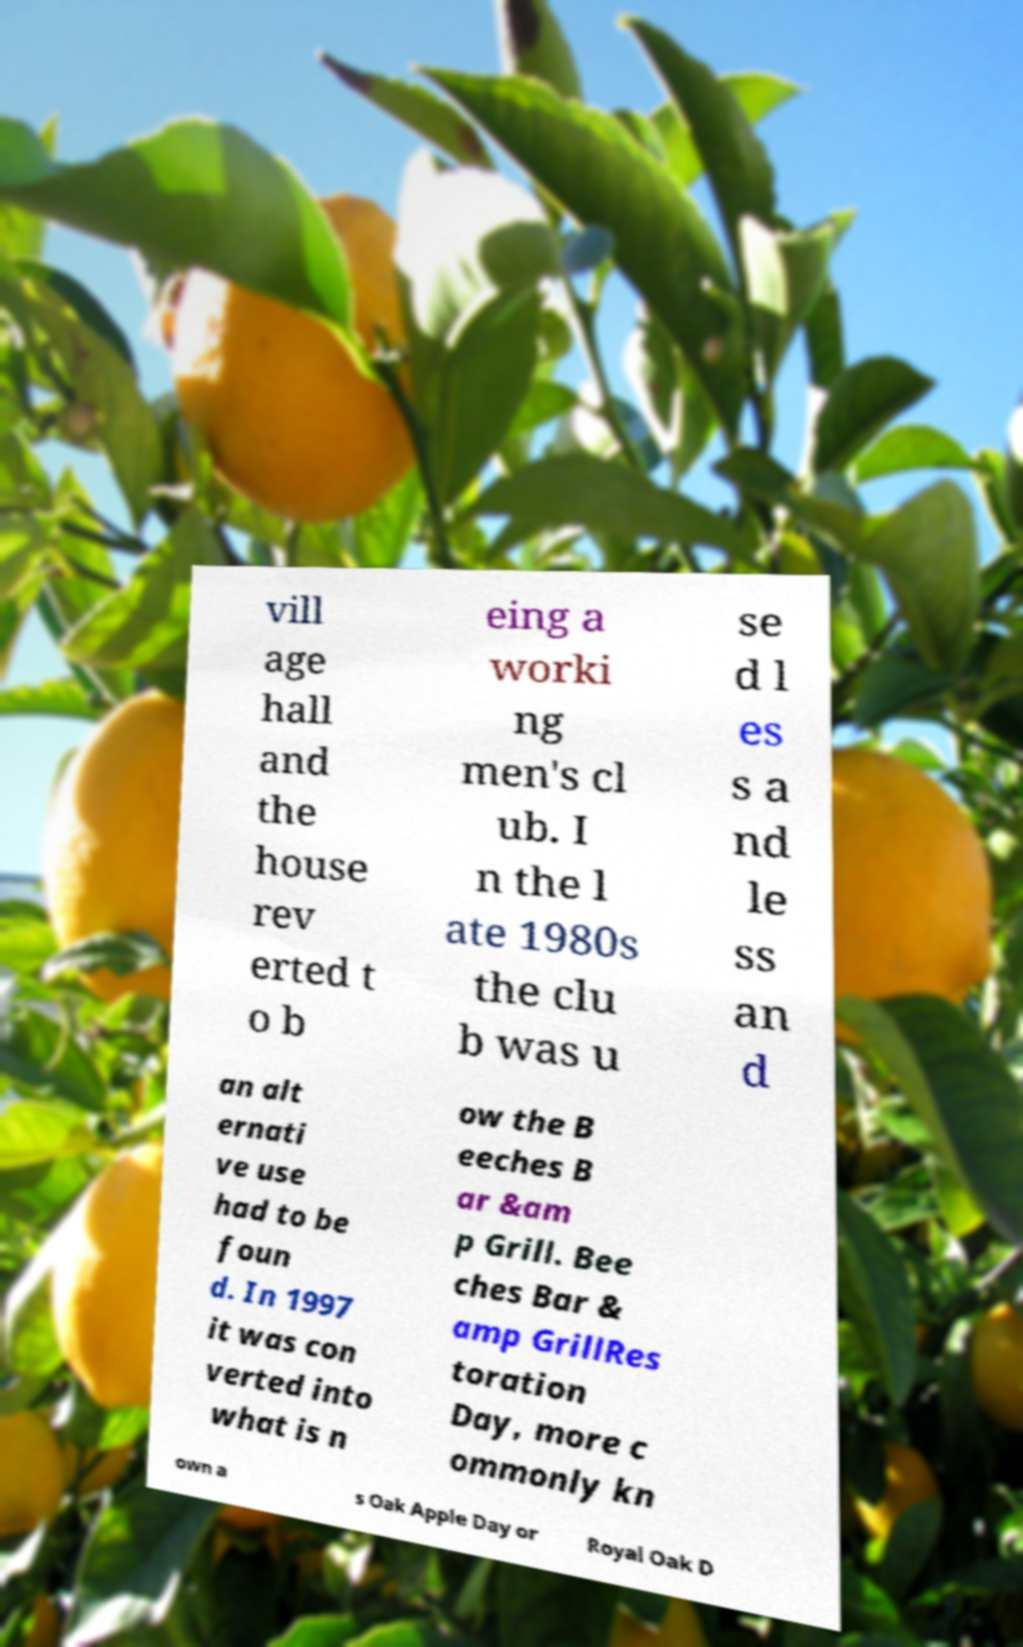There's text embedded in this image that I need extracted. Can you transcribe it verbatim? vill age hall and the house rev erted t o b eing a worki ng men's cl ub. I n the l ate 1980s the clu b was u se d l es s a nd le ss an d an alt ernati ve use had to be foun d. In 1997 it was con verted into what is n ow the B eeches B ar &am p Grill. Bee ches Bar & amp GrillRes toration Day, more c ommonly kn own a s Oak Apple Day or Royal Oak D 